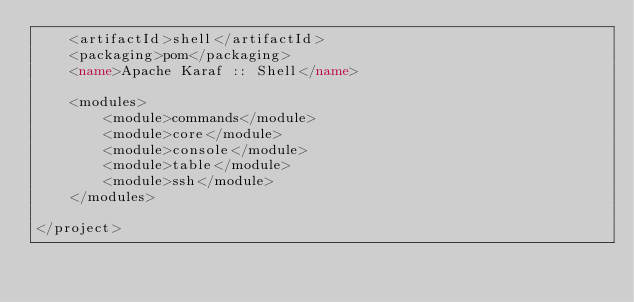<code> <loc_0><loc_0><loc_500><loc_500><_XML_>    <artifactId>shell</artifactId>
    <packaging>pom</packaging>
    <name>Apache Karaf :: Shell</name>

    <modules>
        <module>commands</module>
        <module>core</module>
        <module>console</module>
        <module>table</module>
        <module>ssh</module>
    </modules>

</project>

</code> 